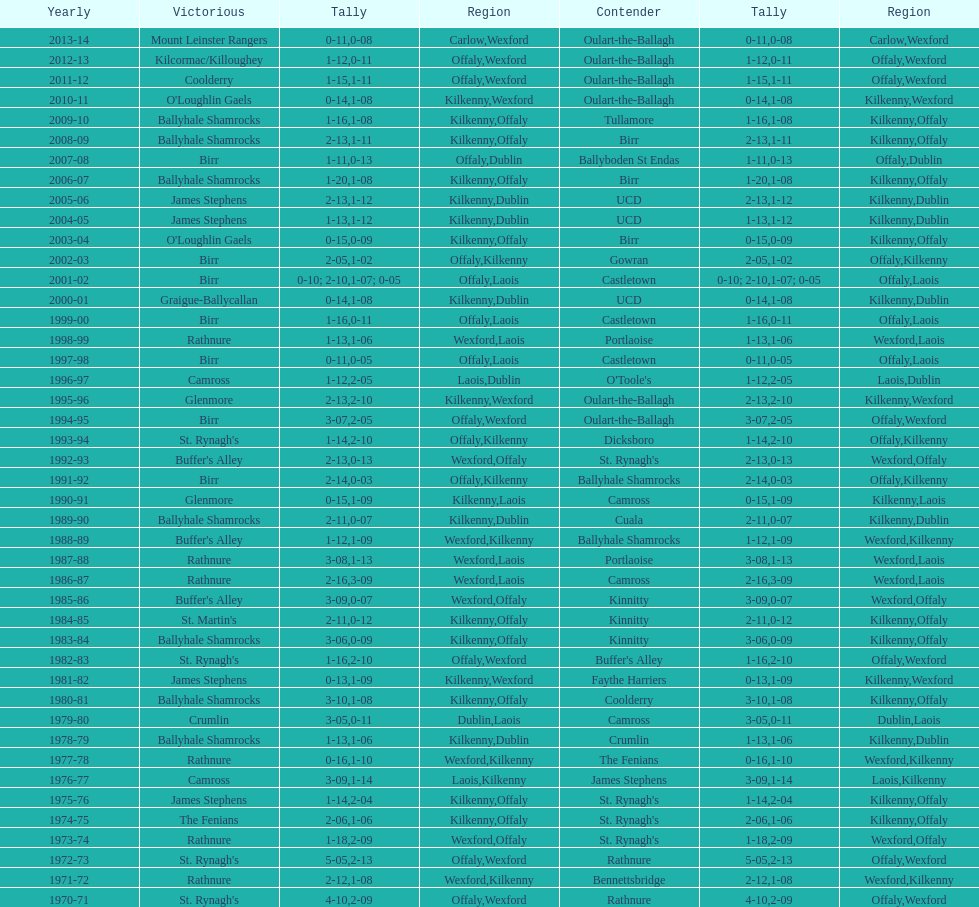In which final season did the leinster senior club hurling championships have a winning margin of less than 11 points? 2007-08. 